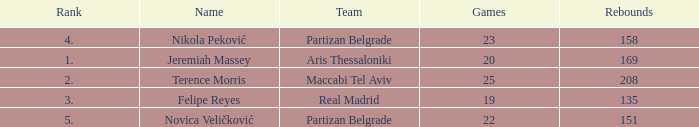How many Rebounds did Novica Veličković get in less than 22 Games? None. 